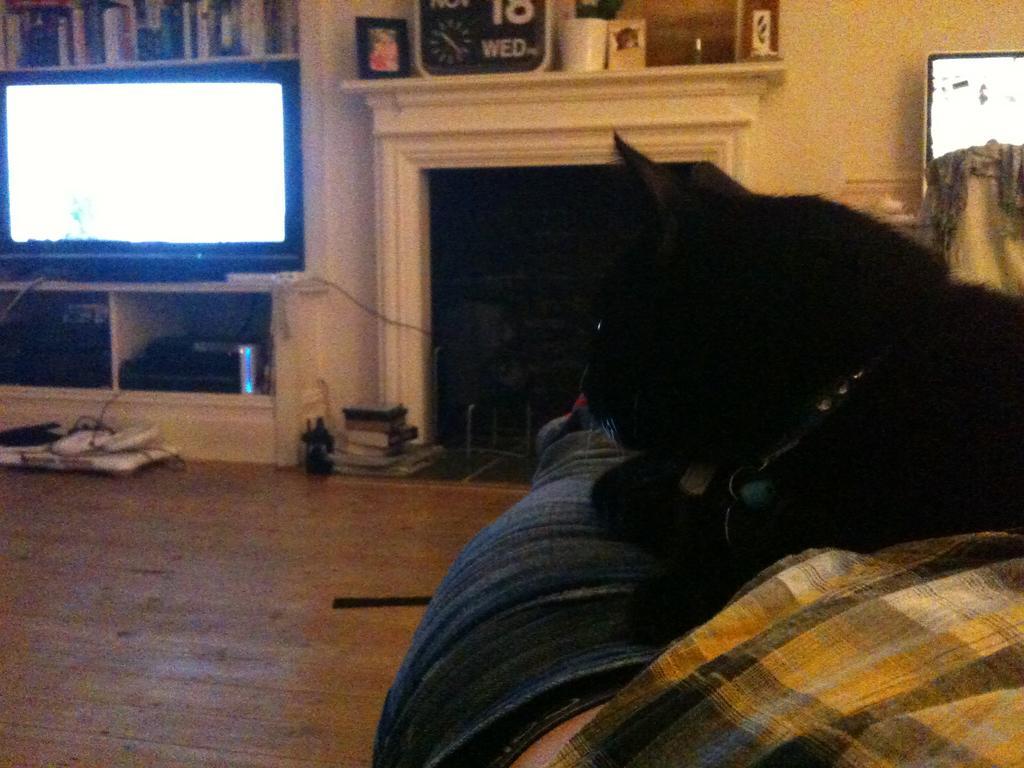Could you give a brief overview of what you see in this image? In this picture we can see a black color cat sitting on a cloth and here we can see floor and on floor remote, books, some instruments and here are the rack full of books and a television, frame with a photo in it and watch, jar. In in background we can see screen, wall. 